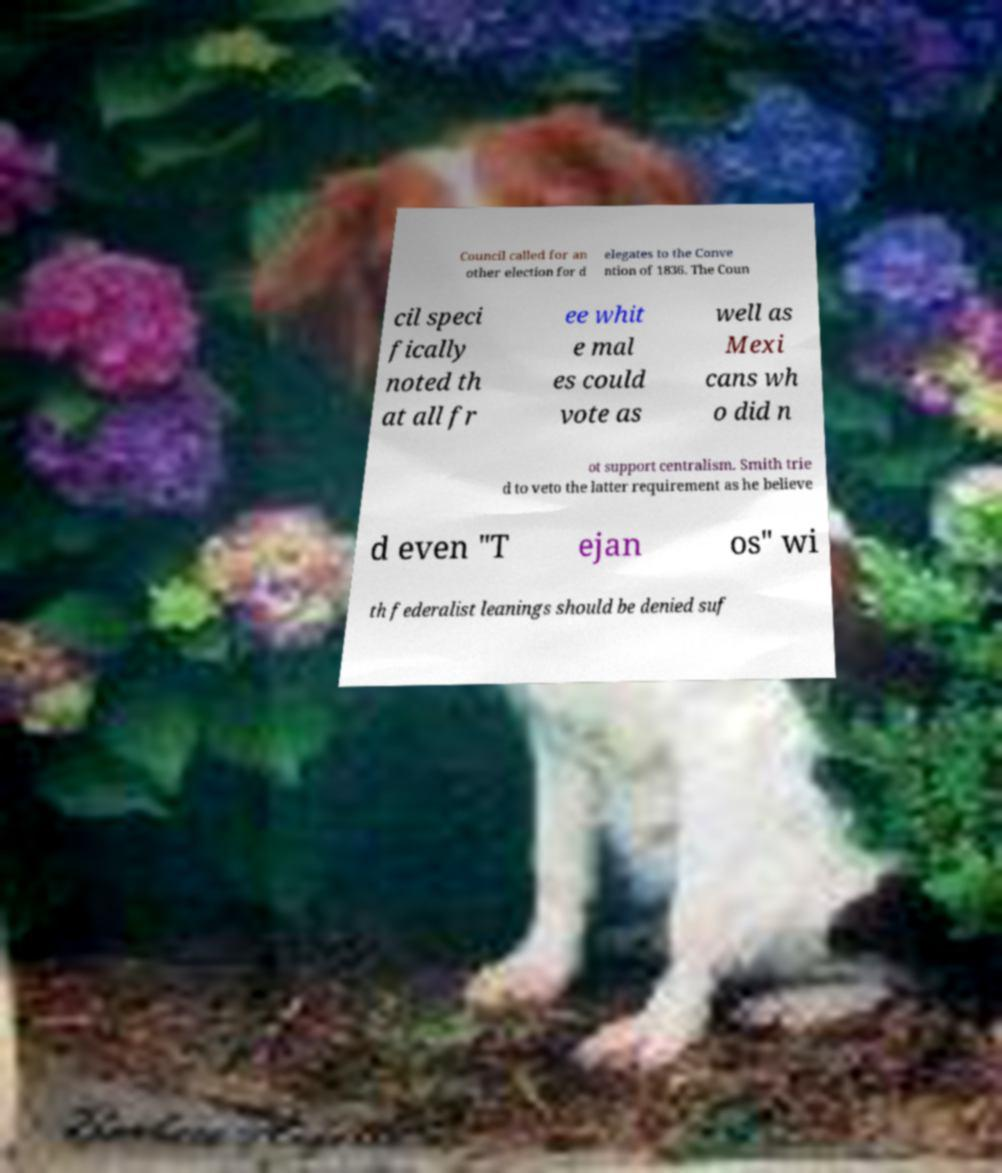Please identify and transcribe the text found in this image. Council called for an other election for d elegates to the Conve ntion of 1836. The Coun cil speci fically noted th at all fr ee whit e mal es could vote as well as Mexi cans wh o did n ot support centralism. Smith trie d to veto the latter requirement as he believe d even "T ejan os" wi th federalist leanings should be denied suf 